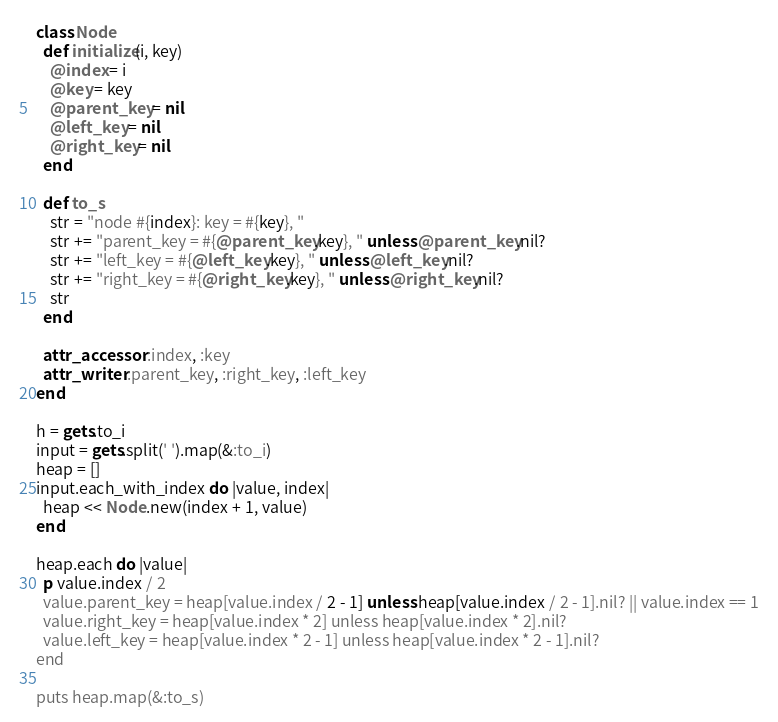<code> <loc_0><loc_0><loc_500><loc_500><_Ruby_>class Node
  def initialize(i, key)
    @index = i
    @key = key
    @parent_key = nil
    @left_key = nil
    @right_key = nil
  end

  def to_s
    str = "node #{index}: key = #{key}, "
    str += "parent_key = #{@parent_key.key}, " unless @parent_key.nil?
    str += "left_key = #{@left_key.key}, " unless @left_key.nil?
    str += "right_key = #{@right_key.key}, " unless @right_key.nil?
    str
  end

  attr_accessor :index, :key
  attr_writer :parent_key, :right_key, :left_key
end

h = gets.to_i
input = gets.split(' ').map(&:to_i)
heap = []
input.each_with_index do |value, index|
  heap << Node.new(index + 1, value)
end

heap.each do |value|
  p value.index / 2
  value.parent_key = heap[value.index / 2 - 1] unless heap[value.index / 2 - 1].nil? || value.index == 1
  value.right_key = heap[value.index * 2] unless heap[value.index * 2].nil?
  value.left_key = heap[value.index * 2 - 1] unless heap[value.index * 2 - 1].nil?
end

puts heap.map(&:to_s)


</code> 